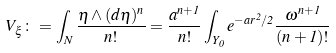<formula> <loc_0><loc_0><loc_500><loc_500>V _ { \xi } \colon = \int _ { N } \frac { \eta \wedge ( d \eta ) ^ { n } } { n ! } = \frac { a ^ { n + 1 } } { n ! } \int _ { Y _ { 0 } } e ^ { - a r ^ { 2 } / 2 } \frac { \omega ^ { n + 1 } } { ( n + 1 ) ! }</formula> 